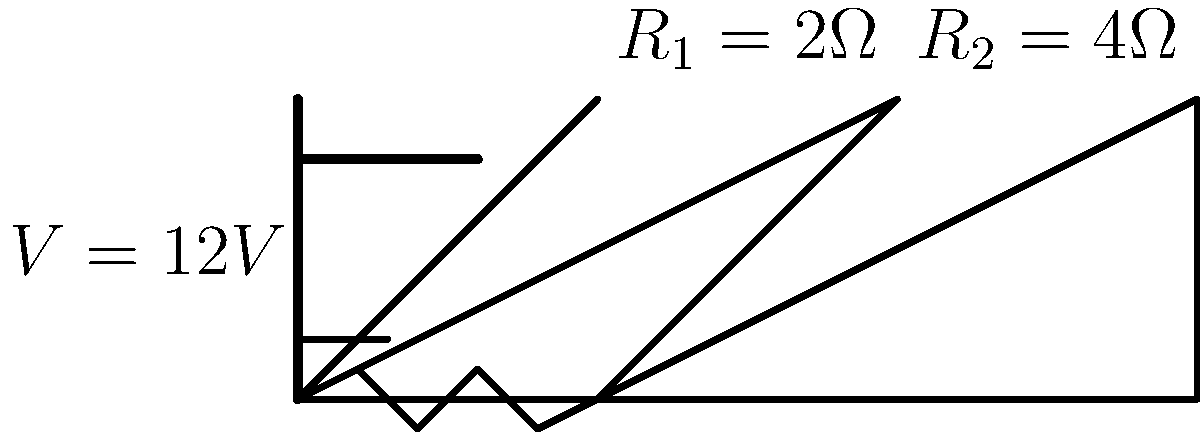In the given circuit diagram, two resistors are connected in series with a battery. If $R_1 = 2\Omega$, $R_2 = 4\Omega$, and the battery voltage is 12V, what is the total current flowing through the circuit? To find the total current flowing through the circuit, we need to follow these steps:

1. Calculate the total resistance of the circuit:
   Since the resistors are in series, we add their values:
   $R_{total} = R_1 + R_2 = 2\Omega + 4\Omega = 6\Omega$

2. Use Ohm's Law to calculate the current:
   Ohm's Law states that $V = IR$, where:
   $V$ is the voltage (12V)
   $I$ is the current (unknown)
   $R$ is the total resistance (6Ω)

   Rearranging the equation to solve for $I$:
   $I = \frac{V}{R} = \frac{12V}{6\Omega} = 2A$

Therefore, the total current flowing through the circuit is 2 amperes.
Answer: 2A 